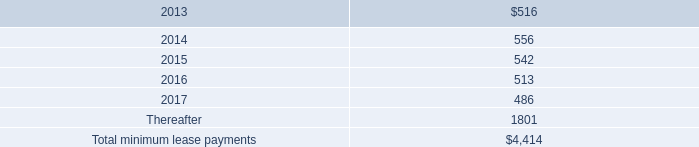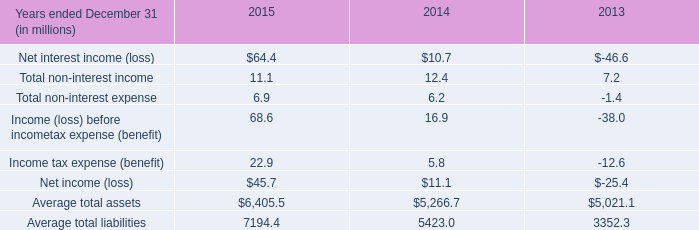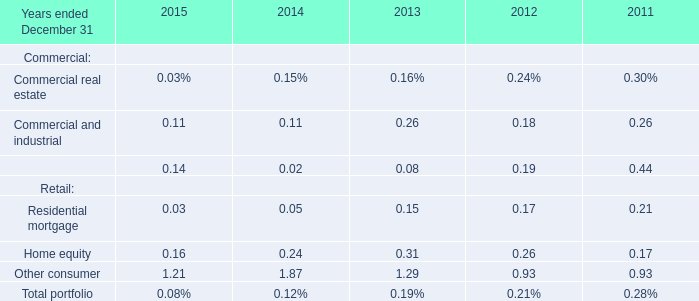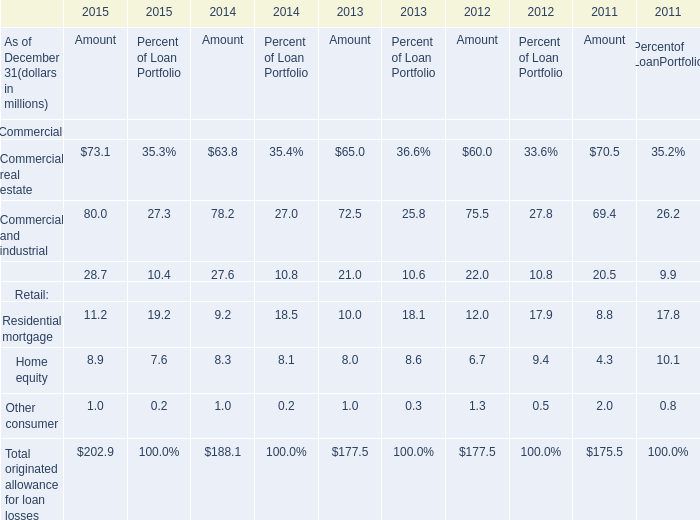What's the increasing rate of Commercial real estate in 2015? 
Computations: ((73.1 - 63.8) / 63.8)
Answer: 0.14577. 